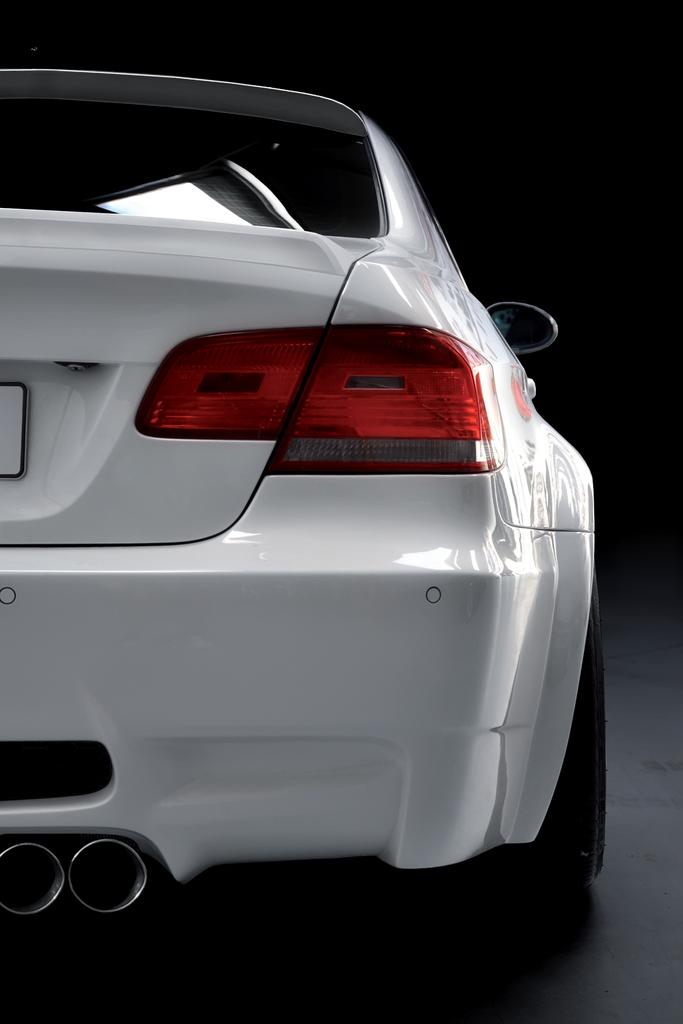What is the main subject of the image? The main subject of the image is a car. Can you describe the appearance of the car? The car is white in color. What type of destruction can be seen happening to the car in the image? There is no destruction present in the image; the car appears to be in good condition. What type of button can be seen on the car in the image? There is no button visible on the car in the image. What type of plate is attached to the car in the image? There is no plate attached to the car in the image. 